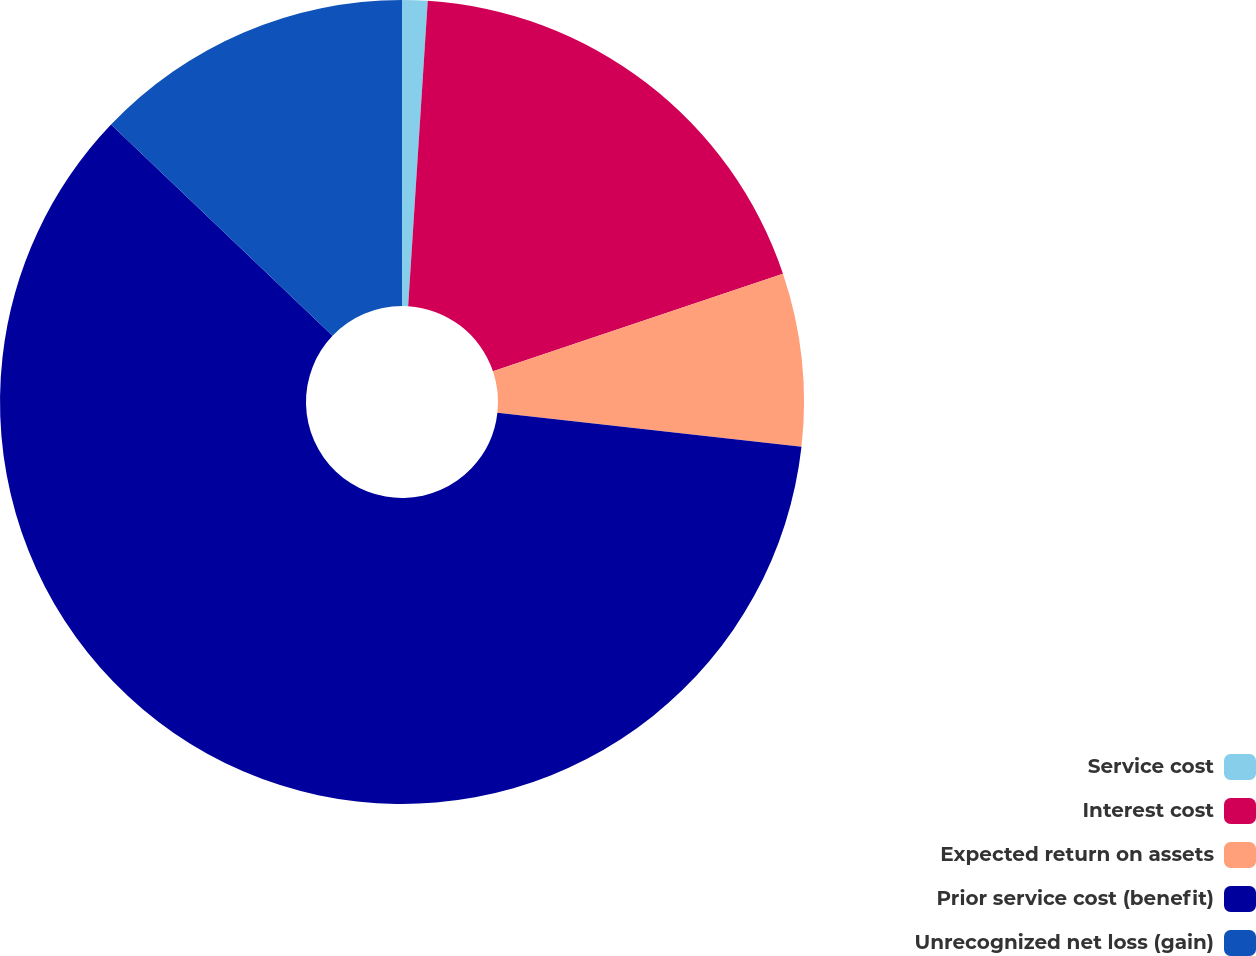Convert chart to OTSL. <chart><loc_0><loc_0><loc_500><loc_500><pie_chart><fcel>Service cost<fcel>Interest cost<fcel>Expected return on assets<fcel>Prior service cost (benefit)<fcel>Unrecognized net loss (gain)<nl><fcel>1.02%<fcel>18.81%<fcel>6.95%<fcel>60.34%<fcel>12.88%<nl></chart> 